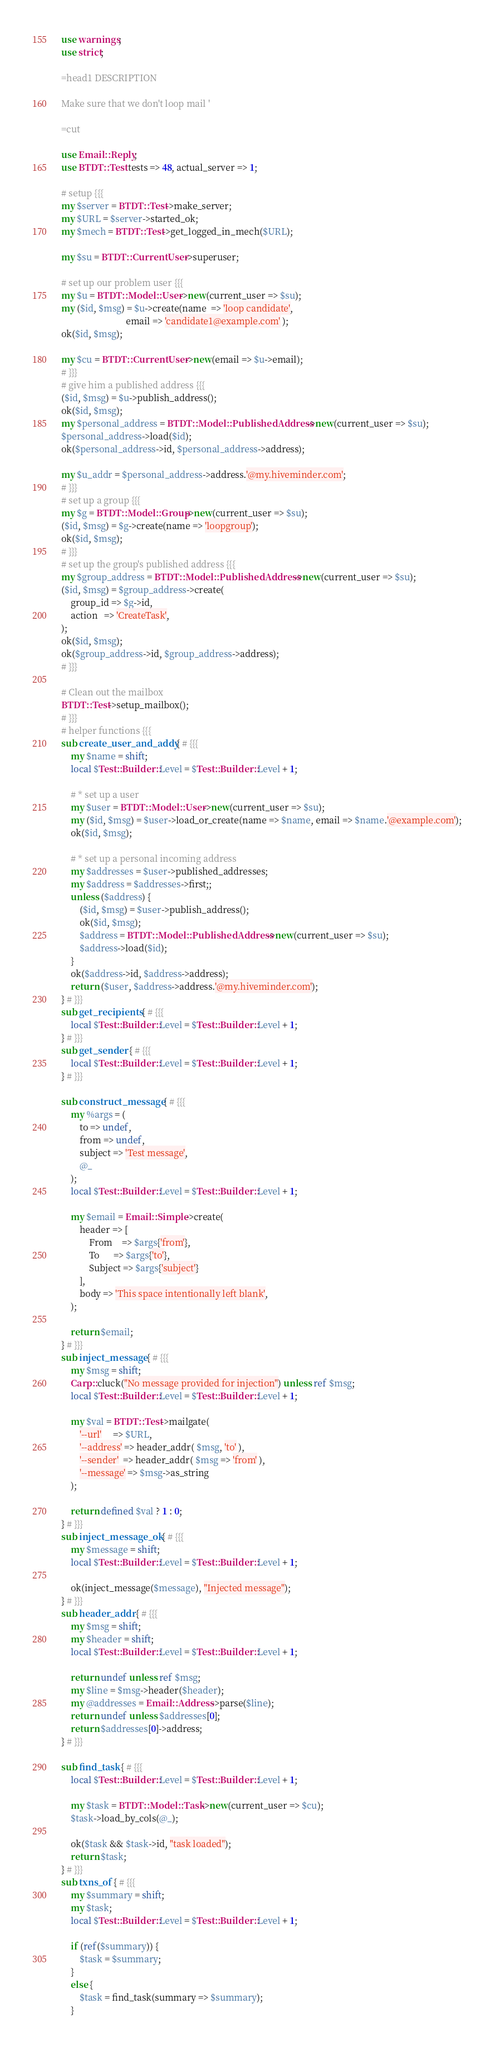Convert code to text. <code><loc_0><loc_0><loc_500><loc_500><_Perl_>use warnings;
use strict;

=head1 DESCRIPTION

Make sure that we don't loop mail '

=cut

use Email::Reply;
use BTDT::Test tests => 48, actual_server => 1;

# setup {{{
my $server = BTDT::Test->make_server;
my $URL = $server->started_ok;
my $mech = BTDT::Test->get_logged_in_mech($URL);

my $su = BTDT::CurrentUser->superuser;

# set up our problem user {{{
my $u = BTDT::Model::User->new(current_user => $su);
my ($id, $msg) = $u->create(name  => 'loop candidate',
                            email => 'candidate1@example.com' );
ok($id, $msg);

my $cu = BTDT::CurrentUser->new(email => $u->email);
# }}}
# give him a published address {{{
($id, $msg) = $u->publish_address();
ok($id, $msg);
my $personal_address = BTDT::Model::PublishedAddress->new(current_user => $su);
$personal_address->load($id);
ok($personal_address->id, $personal_address->address);

my $u_addr = $personal_address->address.'@my.hiveminder.com';
# }}}
# set up a group {{{
my $g = BTDT::Model::Group->new(current_user => $su);
($id, $msg) = $g->create(name => 'loopgroup');
ok($id, $msg);
# }}}
# set up the group's published address {{{
my $group_address = BTDT::Model::PublishedAddress->new(current_user => $su);
($id, $msg) = $group_address->create(
    group_id => $g->id,
    action   => 'CreateTask',
);
ok($id, $msg);
ok($group_address->id, $group_address->address);
# }}}

# Clean out the mailbox
BTDT::Test->setup_mailbox();
# }}}
# helper functions {{{
sub create_user_and_addy { # {{{
    my $name = shift;
    local $Test::Builder::Level = $Test::Builder::Level + 1;

    # * set up a user
    my $user = BTDT::Model::User->new(current_user => $su);
    my ($id, $msg) = $user->load_or_create(name => $name, email => $name.'@example.com');
    ok($id, $msg);

    # * set up a personal incoming address
    my $addresses = $user->published_addresses;
    my $address = $addresses->first;;
    unless ($address) {
        ($id, $msg) = $user->publish_address();
        ok($id, $msg);
        $address = BTDT::Model::PublishedAddress->new(current_user => $su);
        $address->load($id);
    }
    ok($address->id, $address->address);
    return ($user, $address->address.'@my.hiveminder.com');
} # }}}
sub get_recipients { # {{{
    local $Test::Builder::Level = $Test::Builder::Level + 1;
} # }}}
sub get_sender { # {{{
    local $Test::Builder::Level = $Test::Builder::Level + 1;
} # }}}

sub construct_message { # {{{
    my %args = (
        to => undef,
        from => undef,
        subject => 'Test message',
        @_
    );
    local $Test::Builder::Level = $Test::Builder::Level + 1;

    my $email = Email::Simple->create(
        header => [
            From    => $args{'from'},
            To      => $args{'to'},
            Subject => $args{'subject'}
        ],
        body => 'This space intentionally left blank',
    );

    return $email;
} # }}}
sub inject_message { # {{{
    my $msg = shift;
    Carp::cluck("No message provided for injection") unless ref $msg;
    local $Test::Builder::Level = $Test::Builder::Level + 1;

    my $val = BTDT::Test->mailgate(
        '--url'     => $URL,
        '--address' => header_addr( $msg, 'to' ),
        '--sender'  => header_addr( $msg => 'from' ),
        '--message' => $msg->as_string
    );

    return defined $val ? 1 : 0;
} # }}}
sub inject_message_ok { # {{{
    my $message = shift;
    local $Test::Builder::Level = $Test::Builder::Level + 1;

    ok(inject_message($message), "Injected message");
} # }}}
sub header_addr { # {{{
    my $msg = shift;
    my $header = shift;
    local $Test::Builder::Level = $Test::Builder::Level + 1;

    return undef unless ref $msg;
    my $line = $msg->header($header);
    my @addresses = Email::Address->parse($line);
    return undef unless $addresses[0];
    return $addresses[0]->address;
} # }}}

sub find_task { # {{{
    local $Test::Builder::Level = $Test::Builder::Level + 1;

    my $task = BTDT::Model::Task->new(current_user => $cu);
    $task->load_by_cols(@_);

    ok($task && $task->id, "task loaded");
    return $task;
} # }}}
sub txns_of { # {{{
    my $summary = shift;
    my $task;
    local $Test::Builder::Level = $Test::Builder::Level + 1;

    if (ref($summary)) {
        $task = $summary;
    }
    else {
        $task = find_task(summary => $summary);
    }
</code> 